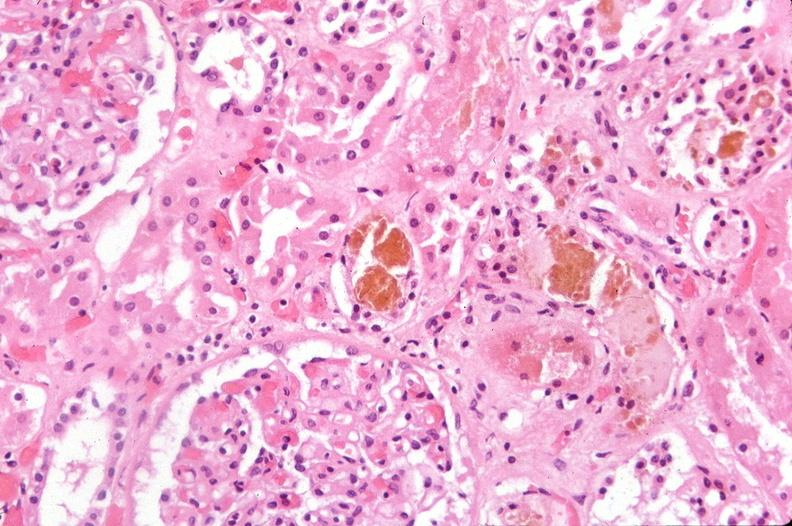what does this image show?
Answer the question using a single word or phrase. Kidney 